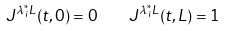Convert formula to latex. <formula><loc_0><loc_0><loc_500><loc_500>J ^ { \lambda _ { i } ^ { \ast } L } ( t , 0 ) = 0 \quad J ^ { \lambda _ { i } ^ { \ast } L } ( t , L ) = 1</formula> 